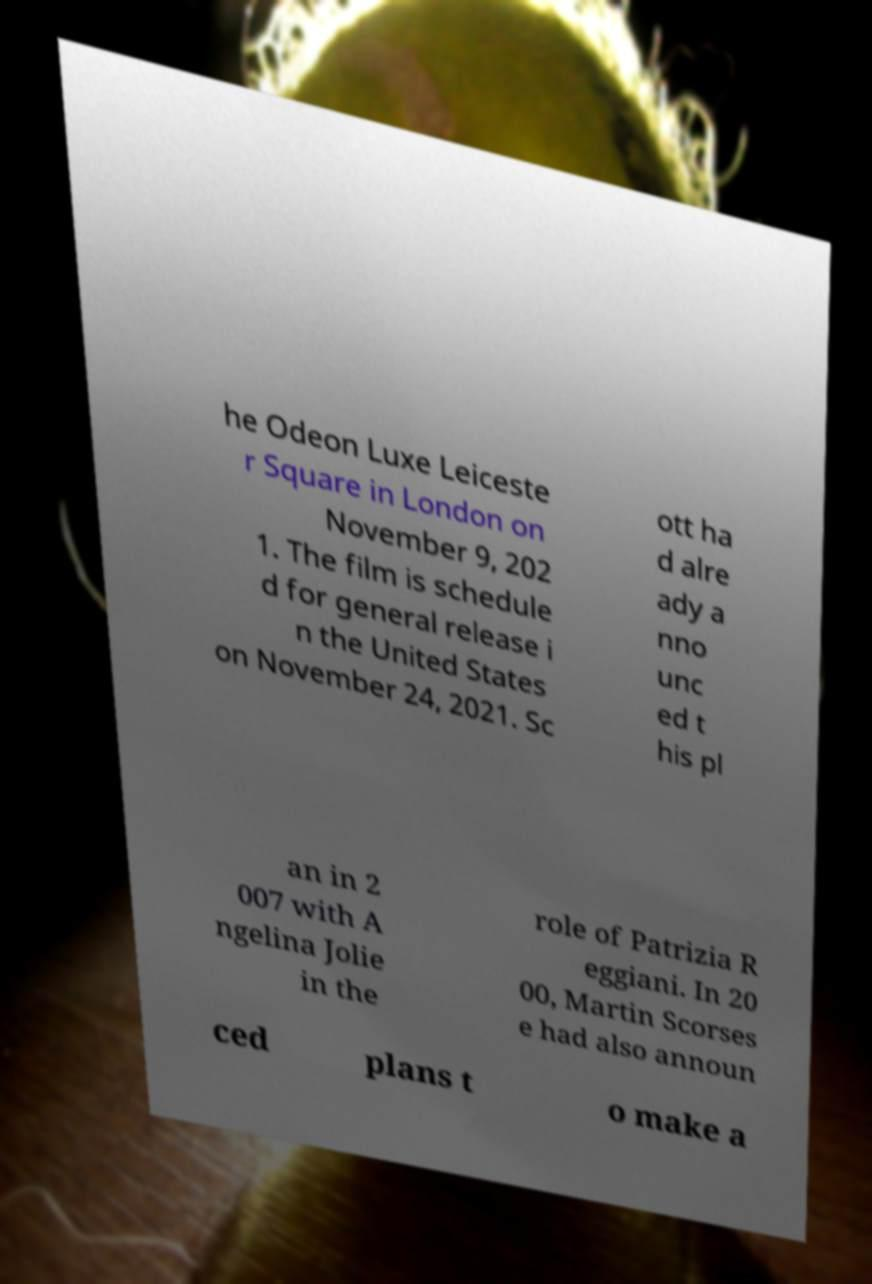For documentation purposes, I need the text within this image transcribed. Could you provide that? he Odeon Luxe Leiceste r Square in London on November 9, 202 1. The film is schedule d for general release i n the United States on November 24, 2021. Sc ott ha d alre ady a nno unc ed t his pl an in 2 007 with A ngelina Jolie in the role of Patrizia R eggiani. In 20 00, Martin Scorses e had also announ ced plans t o make a 